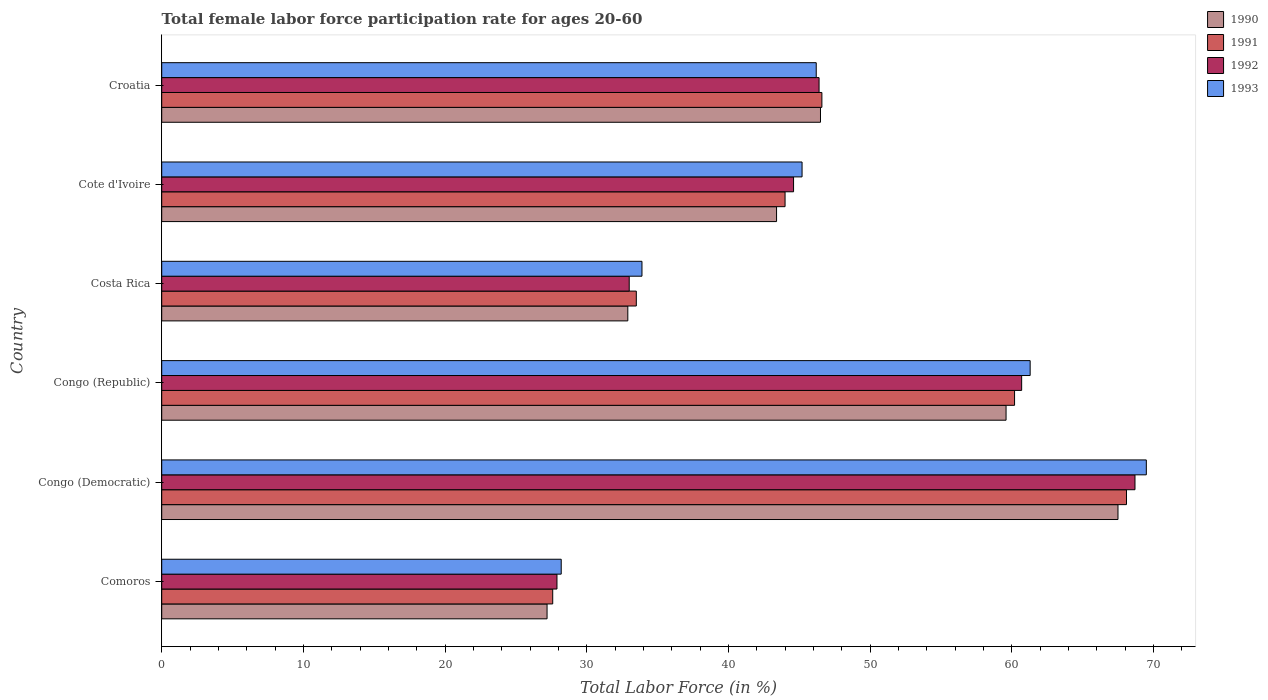Are the number of bars per tick equal to the number of legend labels?
Ensure brevity in your answer.  Yes. Are the number of bars on each tick of the Y-axis equal?
Your answer should be very brief. Yes. What is the label of the 2nd group of bars from the top?
Provide a short and direct response. Cote d'Ivoire. In how many cases, is the number of bars for a given country not equal to the number of legend labels?
Ensure brevity in your answer.  0. What is the female labor force participation rate in 1990 in Congo (Democratic)?
Your response must be concise. 67.5. Across all countries, what is the maximum female labor force participation rate in 1990?
Your answer should be very brief. 67.5. Across all countries, what is the minimum female labor force participation rate in 1993?
Give a very brief answer. 28.2. In which country was the female labor force participation rate in 1990 maximum?
Your response must be concise. Congo (Democratic). In which country was the female labor force participation rate in 1993 minimum?
Give a very brief answer. Comoros. What is the total female labor force participation rate in 1991 in the graph?
Provide a succinct answer. 280. What is the difference between the female labor force participation rate in 1990 in Comoros and that in Cote d'Ivoire?
Your response must be concise. -16.2. What is the difference between the female labor force participation rate in 1992 in Comoros and the female labor force participation rate in 1990 in Cote d'Ivoire?
Offer a very short reply. -15.5. What is the average female labor force participation rate in 1991 per country?
Provide a short and direct response. 46.67. In how many countries, is the female labor force participation rate in 1991 greater than 66 %?
Keep it short and to the point. 1. What is the ratio of the female labor force participation rate in 1991 in Comoros to that in Croatia?
Offer a terse response. 0.59. What is the difference between the highest and the second highest female labor force participation rate in 1990?
Offer a very short reply. 7.9. What is the difference between the highest and the lowest female labor force participation rate in 1992?
Keep it short and to the point. 40.8. In how many countries, is the female labor force participation rate in 1991 greater than the average female labor force participation rate in 1991 taken over all countries?
Offer a terse response. 2. Is the sum of the female labor force participation rate in 1990 in Congo (Republic) and Cote d'Ivoire greater than the maximum female labor force participation rate in 1992 across all countries?
Your response must be concise. Yes. What does the 4th bar from the top in Congo (Democratic) represents?
Make the answer very short. 1990. Is it the case that in every country, the sum of the female labor force participation rate in 1990 and female labor force participation rate in 1993 is greater than the female labor force participation rate in 1991?
Offer a terse response. Yes. How many bars are there?
Keep it short and to the point. 24. How many countries are there in the graph?
Give a very brief answer. 6. Where does the legend appear in the graph?
Your answer should be very brief. Top right. How many legend labels are there?
Make the answer very short. 4. What is the title of the graph?
Your answer should be compact. Total female labor force participation rate for ages 20-60. What is the label or title of the X-axis?
Provide a short and direct response. Total Labor Force (in %). What is the Total Labor Force (in %) in 1990 in Comoros?
Your answer should be compact. 27.2. What is the Total Labor Force (in %) in 1991 in Comoros?
Offer a very short reply. 27.6. What is the Total Labor Force (in %) of 1992 in Comoros?
Provide a succinct answer. 27.9. What is the Total Labor Force (in %) in 1993 in Comoros?
Offer a very short reply. 28.2. What is the Total Labor Force (in %) in 1990 in Congo (Democratic)?
Your answer should be very brief. 67.5. What is the Total Labor Force (in %) of 1991 in Congo (Democratic)?
Keep it short and to the point. 68.1. What is the Total Labor Force (in %) of 1992 in Congo (Democratic)?
Give a very brief answer. 68.7. What is the Total Labor Force (in %) in 1993 in Congo (Democratic)?
Provide a short and direct response. 69.5. What is the Total Labor Force (in %) of 1990 in Congo (Republic)?
Make the answer very short. 59.6. What is the Total Labor Force (in %) in 1991 in Congo (Republic)?
Ensure brevity in your answer.  60.2. What is the Total Labor Force (in %) in 1992 in Congo (Republic)?
Your answer should be very brief. 60.7. What is the Total Labor Force (in %) in 1993 in Congo (Republic)?
Offer a very short reply. 61.3. What is the Total Labor Force (in %) in 1990 in Costa Rica?
Provide a succinct answer. 32.9. What is the Total Labor Force (in %) of 1991 in Costa Rica?
Your answer should be compact. 33.5. What is the Total Labor Force (in %) in 1992 in Costa Rica?
Your response must be concise. 33. What is the Total Labor Force (in %) of 1993 in Costa Rica?
Provide a short and direct response. 33.9. What is the Total Labor Force (in %) in 1990 in Cote d'Ivoire?
Your response must be concise. 43.4. What is the Total Labor Force (in %) of 1991 in Cote d'Ivoire?
Offer a terse response. 44. What is the Total Labor Force (in %) of 1992 in Cote d'Ivoire?
Your response must be concise. 44.6. What is the Total Labor Force (in %) of 1993 in Cote d'Ivoire?
Keep it short and to the point. 45.2. What is the Total Labor Force (in %) in 1990 in Croatia?
Make the answer very short. 46.5. What is the Total Labor Force (in %) in 1991 in Croatia?
Your response must be concise. 46.6. What is the Total Labor Force (in %) of 1992 in Croatia?
Offer a terse response. 46.4. What is the Total Labor Force (in %) in 1993 in Croatia?
Give a very brief answer. 46.2. Across all countries, what is the maximum Total Labor Force (in %) of 1990?
Keep it short and to the point. 67.5. Across all countries, what is the maximum Total Labor Force (in %) in 1991?
Your answer should be very brief. 68.1. Across all countries, what is the maximum Total Labor Force (in %) of 1992?
Your answer should be compact. 68.7. Across all countries, what is the maximum Total Labor Force (in %) in 1993?
Provide a short and direct response. 69.5. Across all countries, what is the minimum Total Labor Force (in %) in 1990?
Make the answer very short. 27.2. Across all countries, what is the minimum Total Labor Force (in %) in 1991?
Offer a terse response. 27.6. Across all countries, what is the minimum Total Labor Force (in %) in 1992?
Make the answer very short. 27.9. Across all countries, what is the minimum Total Labor Force (in %) of 1993?
Offer a very short reply. 28.2. What is the total Total Labor Force (in %) of 1990 in the graph?
Offer a terse response. 277.1. What is the total Total Labor Force (in %) in 1991 in the graph?
Give a very brief answer. 280. What is the total Total Labor Force (in %) in 1992 in the graph?
Your answer should be compact. 281.3. What is the total Total Labor Force (in %) in 1993 in the graph?
Your response must be concise. 284.3. What is the difference between the Total Labor Force (in %) of 1990 in Comoros and that in Congo (Democratic)?
Make the answer very short. -40.3. What is the difference between the Total Labor Force (in %) of 1991 in Comoros and that in Congo (Democratic)?
Give a very brief answer. -40.5. What is the difference between the Total Labor Force (in %) in 1992 in Comoros and that in Congo (Democratic)?
Offer a terse response. -40.8. What is the difference between the Total Labor Force (in %) in 1993 in Comoros and that in Congo (Democratic)?
Give a very brief answer. -41.3. What is the difference between the Total Labor Force (in %) in 1990 in Comoros and that in Congo (Republic)?
Your answer should be very brief. -32.4. What is the difference between the Total Labor Force (in %) of 1991 in Comoros and that in Congo (Republic)?
Your response must be concise. -32.6. What is the difference between the Total Labor Force (in %) in 1992 in Comoros and that in Congo (Republic)?
Ensure brevity in your answer.  -32.8. What is the difference between the Total Labor Force (in %) in 1993 in Comoros and that in Congo (Republic)?
Offer a terse response. -33.1. What is the difference between the Total Labor Force (in %) in 1990 in Comoros and that in Costa Rica?
Offer a terse response. -5.7. What is the difference between the Total Labor Force (in %) of 1991 in Comoros and that in Costa Rica?
Provide a short and direct response. -5.9. What is the difference between the Total Labor Force (in %) in 1992 in Comoros and that in Costa Rica?
Offer a terse response. -5.1. What is the difference between the Total Labor Force (in %) of 1990 in Comoros and that in Cote d'Ivoire?
Provide a succinct answer. -16.2. What is the difference between the Total Labor Force (in %) of 1991 in Comoros and that in Cote d'Ivoire?
Your answer should be very brief. -16.4. What is the difference between the Total Labor Force (in %) in 1992 in Comoros and that in Cote d'Ivoire?
Make the answer very short. -16.7. What is the difference between the Total Labor Force (in %) of 1993 in Comoros and that in Cote d'Ivoire?
Your answer should be very brief. -17. What is the difference between the Total Labor Force (in %) of 1990 in Comoros and that in Croatia?
Provide a succinct answer. -19.3. What is the difference between the Total Labor Force (in %) in 1991 in Comoros and that in Croatia?
Your answer should be compact. -19. What is the difference between the Total Labor Force (in %) of 1992 in Comoros and that in Croatia?
Provide a short and direct response. -18.5. What is the difference between the Total Labor Force (in %) in 1990 in Congo (Democratic) and that in Costa Rica?
Make the answer very short. 34.6. What is the difference between the Total Labor Force (in %) of 1991 in Congo (Democratic) and that in Costa Rica?
Your answer should be very brief. 34.6. What is the difference between the Total Labor Force (in %) of 1992 in Congo (Democratic) and that in Costa Rica?
Your answer should be compact. 35.7. What is the difference between the Total Labor Force (in %) in 1993 in Congo (Democratic) and that in Costa Rica?
Make the answer very short. 35.6. What is the difference between the Total Labor Force (in %) of 1990 in Congo (Democratic) and that in Cote d'Ivoire?
Ensure brevity in your answer.  24.1. What is the difference between the Total Labor Force (in %) of 1991 in Congo (Democratic) and that in Cote d'Ivoire?
Provide a short and direct response. 24.1. What is the difference between the Total Labor Force (in %) in 1992 in Congo (Democratic) and that in Cote d'Ivoire?
Provide a succinct answer. 24.1. What is the difference between the Total Labor Force (in %) in 1993 in Congo (Democratic) and that in Cote d'Ivoire?
Your response must be concise. 24.3. What is the difference between the Total Labor Force (in %) in 1990 in Congo (Democratic) and that in Croatia?
Your answer should be compact. 21. What is the difference between the Total Labor Force (in %) of 1992 in Congo (Democratic) and that in Croatia?
Your response must be concise. 22.3. What is the difference between the Total Labor Force (in %) in 1993 in Congo (Democratic) and that in Croatia?
Your answer should be compact. 23.3. What is the difference between the Total Labor Force (in %) in 1990 in Congo (Republic) and that in Costa Rica?
Offer a terse response. 26.7. What is the difference between the Total Labor Force (in %) in 1991 in Congo (Republic) and that in Costa Rica?
Make the answer very short. 26.7. What is the difference between the Total Labor Force (in %) of 1992 in Congo (Republic) and that in Costa Rica?
Your answer should be compact. 27.7. What is the difference between the Total Labor Force (in %) of 1993 in Congo (Republic) and that in Costa Rica?
Your answer should be very brief. 27.4. What is the difference between the Total Labor Force (in %) in 1990 in Congo (Republic) and that in Croatia?
Ensure brevity in your answer.  13.1. What is the difference between the Total Labor Force (in %) in 1991 in Congo (Republic) and that in Croatia?
Give a very brief answer. 13.6. What is the difference between the Total Labor Force (in %) of 1992 in Congo (Republic) and that in Croatia?
Provide a succinct answer. 14.3. What is the difference between the Total Labor Force (in %) in 1990 in Costa Rica and that in Cote d'Ivoire?
Make the answer very short. -10.5. What is the difference between the Total Labor Force (in %) of 1992 in Costa Rica and that in Cote d'Ivoire?
Keep it short and to the point. -11.6. What is the difference between the Total Labor Force (in %) in 1993 in Costa Rica and that in Cote d'Ivoire?
Give a very brief answer. -11.3. What is the difference between the Total Labor Force (in %) in 1991 in Costa Rica and that in Croatia?
Your answer should be very brief. -13.1. What is the difference between the Total Labor Force (in %) in 1993 in Costa Rica and that in Croatia?
Provide a short and direct response. -12.3. What is the difference between the Total Labor Force (in %) of 1990 in Cote d'Ivoire and that in Croatia?
Keep it short and to the point. -3.1. What is the difference between the Total Labor Force (in %) in 1992 in Cote d'Ivoire and that in Croatia?
Make the answer very short. -1.8. What is the difference between the Total Labor Force (in %) of 1993 in Cote d'Ivoire and that in Croatia?
Your answer should be compact. -1. What is the difference between the Total Labor Force (in %) of 1990 in Comoros and the Total Labor Force (in %) of 1991 in Congo (Democratic)?
Offer a terse response. -40.9. What is the difference between the Total Labor Force (in %) of 1990 in Comoros and the Total Labor Force (in %) of 1992 in Congo (Democratic)?
Keep it short and to the point. -41.5. What is the difference between the Total Labor Force (in %) of 1990 in Comoros and the Total Labor Force (in %) of 1993 in Congo (Democratic)?
Provide a short and direct response. -42.3. What is the difference between the Total Labor Force (in %) in 1991 in Comoros and the Total Labor Force (in %) in 1992 in Congo (Democratic)?
Provide a short and direct response. -41.1. What is the difference between the Total Labor Force (in %) in 1991 in Comoros and the Total Labor Force (in %) in 1993 in Congo (Democratic)?
Make the answer very short. -41.9. What is the difference between the Total Labor Force (in %) in 1992 in Comoros and the Total Labor Force (in %) in 1993 in Congo (Democratic)?
Your answer should be very brief. -41.6. What is the difference between the Total Labor Force (in %) in 1990 in Comoros and the Total Labor Force (in %) in 1991 in Congo (Republic)?
Make the answer very short. -33. What is the difference between the Total Labor Force (in %) of 1990 in Comoros and the Total Labor Force (in %) of 1992 in Congo (Republic)?
Offer a very short reply. -33.5. What is the difference between the Total Labor Force (in %) in 1990 in Comoros and the Total Labor Force (in %) in 1993 in Congo (Republic)?
Offer a terse response. -34.1. What is the difference between the Total Labor Force (in %) of 1991 in Comoros and the Total Labor Force (in %) of 1992 in Congo (Republic)?
Ensure brevity in your answer.  -33.1. What is the difference between the Total Labor Force (in %) of 1991 in Comoros and the Total Labor Force (in %) of 1993 in Congo (Republic)?
Offer a very short reply. -33.7. What is the difference between the Total Labor Force (in %) in 1992 in Comoros and the Total Labor Force (in %) in 1993 in Congo (Republic)?
Offer a very short reply. -33.4. What is the difference between the Total Labor Force (in %) of 1990 in Comoros and the Total Labor Force (in %) of 1992 in Costa Rica?
Offer a terse response. -5.8. What is the difference between the Total Labor Force (in %) in 1991 in Comoros and the Total Labor Force (in %) in 1993 in Costa Rica?
Offer a terse response. -6.3. What is the difference between the Total Labor Force (in %) in 1992 in Comoros and the Total Labor Force (in %) in 1993 in Costa Rica?
Offer a very short reply. -6. What is the difference between the Total Labor Force (in %) of 1990 in Comoros and the Total Labor Force (in %) of 1991 in Cote d'Ivoire?
Make the answer very short. -16.8. What is the difference between the Total Labor Force (in %) of 1990 in Comoros and the Total Labor Force (in %) of 1992 in Cote d'Ivoire?
Offer a very short reply. -17.4. What is the difference between the Total Labor Force (in %) of 1991 in Comoros and the Total Labor Force (in %) of 1992 in Cote d'Ivoire?
Keep it short and to the point. -17. What is the difference between the Total Labor Force (in %) in 1991 in Comoros and the Total Labor Force (in %) in 1993 in Cote d'Ivoire?
Give a very brief answer. -17.6. What is the difference between the Total Labor Force (in %) in 1992 in Comoros and the Total Labor Force (in %) in 1993 in Cote d'Ivoire?
Your answer should be very brief. -17.3. What is the difference between the Total Labor Force (in %) in 1990 in Comoros and the Total Labor Force (in %) in 1991 in Croatia?
Make the answer very short. -19.4. What is the difference between the Total Labor Force (in %) in 1990 in Comoros and the Total Labor Force (in %) in 1992 in Croatia?
Keep it short and to the point. -19.2. What is the difference between the Total Labor Force (in %) in 1990 in Comoros and the Total Labor Force (in %) in 1993 in Croatia?
Offer a very short reply. -19. What is the difference between the Total Labor Force (in %) of 1991 in Comoros and the Total Labor Force (in %) of 1992 in Croatia?
Your answer should be very brief. -18.8. What is the difference between the Total Labor Force (in %) of 1991 in Comoros and the Total Labor Force (in %) of 1993 in Croatia?
Make the answer very short. -18.6. What is the difference between the Total Labor Force (in %) of 1992 in Comoros and the Total Labor Force (in %) of 1993 in Croatia?
Give a very brief answer. -18.3. What is the difference between the Total Labor Force (in %) of 1990 in Congo (Democratic) and the Total Labor Force (in %) of 1991 in Congo (Republic)?
Offer a very short reply. 7.3. What is the difference between the Total Labor Force (in %) in 1990 in Congo (Democratic) and the Total Labor Force (in %) in 1992 in Congo (Republic)?
Provide a short and direct response. 6.8. What is the difference between the Total Labor Force (in %) in 1991 in Congo (Democratic) and the Total Labor Force (in %) in 1992 in Congo (Republic)?
Your answer should be very brief. 7.4. What is the difference between the Total Labor Force (in %) in 1990 in Congo (Democratic) and the Total Labor Force (in %) in 1992 in Costa Rica?
Your response must be concise. 34.5. What is the difference between the Total Labor Force (in %) of 1990 in Congo (Democratic) and the Total Labor Force (in %) of 1993 in Costa Rica?
Provide a short and direct response. 33.6. What is the difference between the Total Labor Force (in %) in 1991 in Congo (Democratic) and the Total Labor Force (in %) in 1992 in Costa Rica?
Keep it short and to the point. 35.1. What is the difference between the Total Labor Force (in %) in 1991 in Congo (Democratic) and the Total Labor Force (in %) in 1993 in Costa Rica?
Keep it short and to the point. 34.2. What is the difference between the Total Labor Force (in %) of 1992 in Congo (Democratic) and the Total Labor Force (in %) of 1993 in Costa Rica?
Ensure brevity in your answer.  34.8. What is the difference between the Total Labor Force (in %) of 1990 in Congo (Democratic) and the Total Labor Force (in %) of 1991 in Cote d'Ivoire?
Offer a very short reply. 23.5. What is the difference between the Total Labor Force (in %) in 1990 in Congo (Democratic) and the Total Labor Force (in %) in 1992 in Cote d'Ivoire?
Your answer should be very brief. 22.9. What is the difference between the Total Labor Force (in %) in 1990 in Congo (Democratic) and the Total Labor Force (in %) in 1993 in Cote d'Ivoire?
Provide a short and direct response. 22.3. What is the difference between the Total Labor Force (in %) of 1991 in Congo (Democratic) and the Total Labor Force (in %) of 1992 in Cote d'Ivoire?
Provide a short and direct response. 23.5. What is the difference between the Total Labor Force (in %) of 1991 in Congo (Democratic) and the Total Labor Force (in %) of 1993 in Cote d'Ivoire?
Make the answer very short. 22.9. What is the difference between the Total Labor Force (in %) in 1990 in Congo (Democratic) and the Total Labor Force (in %) in 1991 in Croatia?
Provide a short and direct response. 20.9. What is the difference between the Total Labor Force (in %) in 1990 in Congo (Democratic) and the Total Labor Force (in %) in 1992 in Croatia?
Your answer should be compact. 21.1. What is the difference between the Total Labor Force (in %) of 1990 in Congo (Democratic) and the Total Labor Force (in %) of 1993 in Croatia?
Your answer should be compact. 21.3. What is the difference between the Total Labor Force (in %) of 1991 in Congo (Democratic) and the Total Labor Force (in %) of 1992 in Croatia?
Your answer should be compact. 21.7. What is the difference between the Total Labor Force (in %) in 1991 in Congo (Democratic) and the Total Labor Force (in %) in 1993 in Croatia?
Your response must be concise. 21.9. What is the difference between the Total Labor Force (in %) of 1992 in Congo (Democratic) and the Total Labor Force (in %) of 1993 in Croatia?
Ensure brevity in your answer.  22.5. What is the difference between the Total Labor Force (in %) of 1990 in Congo (Republic) and the Total Labor Force (in %) of 1991 in Costa Rica?
Your answer should be compact. 26.1. What is the difference between the Total Labor Force (in %) in 1990 in Congo (Republic) and the Total Labor Force (in %) in 1992 in Costa Rica?
Your answer should be very brief. 26.6. What is the difference between the Total Labor Force (in %) of 1990 in Congo (Republic) and the Total Labor Force (in %) of 1993 in Costa Rica?
Provide a short and direct response. 25.7. What is the difference between the Total Labor Force (in %) in 1991 in Congo (Republic) and the Total Labor Force (in %) in 1992 in Costa Rica?
Keep it short and to the point. 27.2. What is the difference between the Total Labor Force (in %) in 1991 in Congo (Republic) and the Total Labor Force (in %) in 1993 in Costa Rica?
Your response must be concise. 26.3. What is the difference between the Total Labor Force (in %) in 1992 in Congo (Republic) and the Total Labor Force (in %) in 1993 in Costa Rica?
Give a very brief answer. 26.8. What is the difference between the Total Labor Force (in %) in 1990 in Congo (Republic) and the Total Labor Force (in %) in 1991 in Cote d'Ivoire?
Your answer should be very brief. 15.6. What is the difference between the Total Labor Force (in %) of 1991 in Congo (Republic) and the Total Labor Force (in %) of 1993 in Cote d'Ivoire?
Offer a very short reply. 15. What is the difference between the Total Labor Force (in %) of 1992 in Congo (Republic) and the Total Labor Force (in %) of 1993 in Cote d'Ivoire?
Ensure brevity in your answer.  15.5. What is the difference between the Total Labor Force (in %) in 1990 in Congo (Republic) and the Total Labor Force (in %) in 1991 in Croatia?
Offer a terse response. 13. What is the difference between the Total Labor Force (in %) in 1991 in Congo (Republic) and the Total Labor Force (in %) in 1992 in Croatia?
Offer a terse response. 13.8. What is the difference between the Total Labor Force (in %) of 1991 in Congo (Republic) and the Total Labor Force (in %) of 1993 in Croatia?
Your answer should be compact. 14. What is the difference between the Total Labor Force (in %) in 1990 in Costa Rica and the Total Labor Force (in %) in 1993 in Cote d'Ivoire?
Offer a terse response. -12.3. What is the difference between the Total Labor Force (in %) of 1991 in Costa Rica and the Total Labor Force (in %) of 1992 in Cote d'Ivoire?
Give a very brief answer. -11.1. What is the difference between the Total Labor Force (in %) of 1990 in Costa Rica and the Total Labor Force (in %) of 1991 in Croatia?
Give a very brief answer. -13.7. What is the difference between the Total Labor Force (in %) in 1990 in Costa Rica and the Total Labor Force (in %) in 1993 in Croatia?
Your answer should be compact. -13.3. What is the difference between the Total Labor Force (in %) of 1991 in Costa Rica and the Total Labor Force (in %) of 1993 in Croatia?
Your response must be concise. -12.7. What is the difference between the Total Labor Force (in %) of 1990 in Cote d'Ivoire and the Total Labor Force (in %) of 1991 in Croatia?
Your answer should be compact. -3.2. What is the difference between the Total Labor Force (in %) in 1990 in Cote d'Ivoire and the Total Labor Force (in %) in 1993 in Croatia?
Offer a terse response. -2.8. What is the difference between the Total Labor Force (in %) in 1991 in Cote d'Ivoire and the Total Labor Force (in %) in 1993 in Croatia?
Keep it short and to the point. -2.2. What is the average Total Labor Force (in %) of 1990 per country?
Offer a very short reply. 46.18. What is the average Total Labor Force (in %) in 1991 per country?
Keep it short and to the point. 46.67. What is the average Total Labor Force (in %) of 1992 per country?
Your answer should be very brief. 46.88. What is the average Total Labor Force (in %) of 1993 per country?
Your answer should be compact. 47.38. What is the difference between the Total Labor Force (in %) of 1990 and Total Labor Force (in %) of 1991 in Comoros?
Keep it short and to the point. -0.4. What is the difference between the Total Labor Force (in %) of 1991 and Total Labor Force (in %) of 1992 in Comoros?
Keep it short and to the point. -0.3. What is the difference between the Total Labor Force (in %) of 1992 and Total Labor Force (in %) of 1993 in Comoros?
Your response must be concise. -0.3. What is the difference between the Total Labor Force (in %) of 1990 and Total Labor Force (in %) of 1991 in Congo (Democratic)?
Keep it short and to the point. -0.6. What is the difference between the Total Labor Force (in %) in 1990 and Total Labor Force (in %) in 1992 in Congo (Democratic)?
Give a very brief answer. -1.2. What is the difference between the Total Labor Force (in %) in 1990 and Total Labor Force (in %) in 1993 in Congo (Democratic)?
Your answer should be compact. -2. What is the difference between the Total Labor Force (in %) of 1991 and Total Labor Force (in %) of 1993 in Congo (Democratic)?
Give a very brief answer. -1.4. What is the difference between the Total Labor Force (in %) in 1992 and Total Labor Force (in %) in 1993 in Congo (Democratic)?
Give a very brief answer. -0.8. What is the difference between the Total Labor Force (in %) of 1990 and Total Labor Force (in %) of 1991 in Congo (Republic)?
Provide a short and direct response. -0.6. What is the difference between the Total Labor Force (in %) of 1990 and Total Labor Force (in %) of 1992 in Congo (Republic)?
Offer a terse response. -1.1. What is the difference between the Total Labor Force (in %) in 1990 and Total Labor Force (in %) in 1993 in Congo (Republic)?
Offer a very short reply. -1.7. What is the difference between the Total Labor Force (in %) of 1990 and Total Labor Force (in %) of 1991 in Costa Rica?
Offer a very short reply. -0.6. What is the difference between the Total Labor Force (in %) of 1990 and Total Labor Force (in %) of 1992 in Costa Rica?
Provide a succinct answer. -0.1. What is the difference between the Total Labor Force (in %) of 1991 and Total Labor Force (in %) of 1993 in Costa Rica?
Provide a succinct answer. -0.4. What is the difference between the Total Labor Force (in %) in 1990 and Total Labor Force (in %) in 1991 in Cote d'Ivoire?
Ensure brevity in your answer.  -0.6. What is the difference between the Total Labor Force (in %) of 1990 and Total Labor Force (in %) of 1993 in Cote d'Ivoire?
Your response must be concise. -1.8. What is the difference between the Total Labor Force (in %) of 1991 and Total Labor Force (in %) of 1993 in Cote d'Ivoire?
Keep it short and to the point. -1.2. What is the difference between the Total Labor Force (in %) in 1990 and Total Labor Force (in %) in 1991 in Croatia?
Make the answer very short. -0.1. What is the ratio of the Total Labor Force (in %) of 1990 in Comoros to that in Congo (Democratic)?
Offer a terse response. 0.4. What is the ratio of the Total Labor Force (in %) in 1991 in Comoros to that in Congo (Democratic)?
Your response must be concise. 0.41. What is the ratio of the Total Labor Force (in %) in 1992 in Comoros to that in Congo (Democratic)?
Keep it short and to the point. 0.41. What is the ratio of the Total Labor Force (in %) of 1993 in Comoros to that in Congo (Democratic)?
Offer a terse response. 0.41. What is the ratio of the Total Labor Force (in %) in 1990 in Comoros to that in Congo (Republic)?
Your answer should be very brief. 0.46. What is the ratio of the Total Labor Force (in %) of 1991 in Comoros to that in Congo (Republic)?
Offer a terse response. 0.46. What is the ratio of the Total Labor Force (in %) of 1992 in Comoros to that in Congo (Republic)?
Your response must be concise. 0.46. What is the ratio of the Total Labor Force (in %) in 1993 in Comoros to that in Congo (Republic)?
Give a very brief answer. 0.46. What is the ratio of the Total Labor Force (in %) in 1990 in Comoros to that in Costa Rica?
Offer a terse response. 0.83. What is the ratio of the Total Labor Force (in %) of 1991 in Comoros to that in Costa Rica?
Keep it short and to the point. 0.82. What is the ratio of the Total Labor Force (in %) in 1992 in Comoros to that in Costa Rica?
Keep it short and to the point. 0.85. What is the ratio of the Total Labor Force (in %) of 1993 in Comoros to that in Costa Rica?
Keep it short and to the point. 0.83. What is the ratio of the Total Labor Force (in %) of 1990 in Comoros to that in Cote d'Ivoire?
Your response must be concise. 0.63. What is the ratio of the Total Labor Force (in %) of 1991 in Comoros to that in Cote d'Ivoire?
Your response must be concise. 0.63. What is the ratio of the Total Labor Force (in %) in 1992 in Comoros to that in Cote d'Ivoire?
Provide a short and direct response. 0.63. What is the ratio of the Total Labor Force (in %) of 1993 in Comoros to that in Cote d'Ivoire?
Offer a terse response. 0.62. What is the ratio of the Total Labor Force (in %) of 1990 in Comoros to that in Croatia?
Keep it short and to the point. 0.58. What is the ratio of the Total Labor Force (in %) of 1991 in Comoros to that in Croatia?
Your answer should be compact. 0.59. What is the ratio of the Total Labor Force (in %) of 1992 in Comoros to that in Croatia?
Give a very brief answer. 0.6. What is the ratio of the Total Labor Force (in %) of 1993 in Comoros to that in Croatia?
Provide a short and direct response. 0.61. What is the ratio of the Total Labor Force (in %) in 1990 in Congo (Democratic) to that in Congo (Republic)?
Provide a succinct answer. 1.13. What is the ratio of the Total Labor Force (in %) of 1991 in Congo (Democratic) to that in Congo (Republic)?
Provide a succinct answer. 1.13. What is the ratio of the Total Labor Force (in %) of 1992 in Congo (Democratic) to that in Congo (Republic)?
Offer a very short reply. 1.13. What is the ratio of the Total Labor Force (in %) in 1993 in Congo (Democratic) to that in Congo (Republic)?
Make the answer very short. 1.13. What is the ratio of the Total Labor Force (in %) in 1990 in Congo (Democratic) to that in Costa Rica?
Offer a very short reply. 2.05. What is the ratio of the Total Labor Force (in %) in 1991 in Congo (Democratic) to that in Costa Rica?
Give a very brief answer. 2.03. What is the ratio of the Total Labor Force (in %) in 1992 in Congo (Democratic) to that in Costa Rica?
Ensure brevity in your answer.  2.08. What is the ratio of the Total Labor Force (in %) in 1993 in Congo (Democratic) to that in Costa Rica?
Your answer should be compact. 2.05. What is the ratio of the Total Labor Force (in %) of 1990 in Congo (Democratic) to that in Cote d'Ivoire?
Give a very brief answer. 1.56. What is the ratio of the Total Labor Force (in %) of 1991 in Congo (Democratic) to that in Cote d'Ivoire?
Your answer should be compact. 1.55. What is the ratio of the Total Labor Force (in %) of 1992 in Congo (Democratic) to that in Cote d'Ivoire?
Give a very brief answer. 1.54. What is the ratio of the Total Labor Force (in %) in 1993 in Congo (Democratic) to that in Cote d'Ivoire?
Give a very brief answer. 1.54. What is the ratio of the Total Labor Force (in %) of 1990 in Congo (Democratic) to that in Croatia?
Give a very brief answer. 1.45. What is the ratio of the Total Labor Force (in %) of 1991 in Congo (Democratic) to that in Croatia?
Offer a terse response. 1.46. What is the ratio of the Total Labor Force (in %) in 1992 in Congo (Democratic) to that in Croatia?
Keep it short and to the point. 1.48. What is the ratio of the Total Labor Force (in %) of 1993 in Congo (Democratic) to that in Croatia?
Provide a succinct answer. 1.5. What is the ratio of the Total Labor Force (in %) of 1990 in Congo (Republic) to that in Costa Rica?
Your answer should be very brief. 1.81. What is the ratio of the Total Labor Force (in %) of 1991 in Congo (Republic) to that in Costa Rica?
Provide a succinct answer. 1.8. What is the ratio of the Total Labor Force (in %) of 1992 in Congo (Republic) to that in Costa Rica?
Provide a short and direct response. 1.84. What is the ratio of the Total Labor Force (in %) in 1993 in Congo (Republic) to that in Costa Rica?
Provide a succinct answer. 1.81. What is the ratio of the Total Labor Force (in %) in 1990 in Congo (Republic) to that in Cote d'Ivoire?
Offer a very short reply. 1.37. What is the ratio of the Total Labor Force (in %) in 1991 in Congo (Republic) to that in Cote d'Ivoire?
Give a very brief answer. 1.37. What is the ratio of the Total Labor Force (in %) of 1992 in Congo (Republic) to that in Cote d'Ivoire?
Make the answer very short. 1.36. What is the ratio of the Total Labor Force (in %) of 1993 in Congo (Republic) to that in Cote d'Ivoire?
Keep it short and to the point. 1.36. What is the ratio of the Total Labor Force (in %) in 1990 in Congo (Republic) to that in Croatia?
Provide a short and direct response. 1.28. What is the ratio of the Total Labor Force (in %) of 1991 in Congo (Republic) to that in Croatia?
Give a very brief answer. 1.29. What is the ratio of the Total Labor Force (in %) in 1992 in Congo (Republic) to that in Croatia?
Your answer should be very brief. 1.31. What is the ratio of the Total Labor Force (in %) in 1993 in Congo (Republic) to that in Croatia?
Keep it short and to the point. 1.33. What is the ratio of the Total Labor Force (in %) in 1990 in Costa Rica to that in Cote d'Ivoire?
Your answer should be very brief. 0.76. What is the ratio of the Total Labor Force (in %) in 1991 in Costa Rica to that in Cote d'Ivoire?
Provide a succinct answer. 0.76. What is the ratio of the Total Labor Force (in %) in 1992 in Costa Rica to that in Cote d'Ivoire?
Your answer should be very brief. 0.74. What is the ratio of the Total Labor Force (in %) in 1990 in Costa Rica to that in Croatia?
Provide a short and direct response. 0.71. What is the ratio of the Total Labor Force (in %) in 1991 in Costa Rica to that in Croatia?
Your answer should be compact. 0.72. What is the ratio of the Total Labor Force (in %) of 1992 in Costa Rica to that in Croatia?
Provide a succinct answer. 0.71. What is the ratio of the Total Labor Force (in %) in 1993 in Costa Rica to that in Croatia?
Give a very brief answer. 0.73. What is the ratio of the Total Labor Force (in %) in 1991 in Cote d'Ivoire to that in Croatia?
Keep it short and to the point. 0.94. What is the ratio of the Total Labor Force (in %) of 1992 in Cote d'Ivoire to that in Croatia?
Your response must be concise. 0.96. What is the ratio of the Total Labor Force (in %) of 1993 in Cote d'Ivoire to that in Croatia?
Provide a succinct answer. 0.98. What is the difference between the highest and the second highest Total Labor Force (in %) of 1990?
Your response must be concise. 7.9. What is the difference between the highest and the second highest Total Labor Force (in %) in 1992?
Make the answer very short. 8. What is the difference between the highest and the second highest Total Labor Force (in %) of 1993?
Keep it short and to the point. 8.2. What is the difference between the highest and the lowest Total Labor Force (in %) of 1990?
Your answer should be compact. 40.3. What is the difference between the highest and the lowest Total Labor Force (in %) in 1991?
Ensure brevity in your answer.  40.5. What is the difference between the highest and the lowest Total Labor Force (in %) in 1992?
Ensure brevity in your answer.  40.8. What is the difference between the highest and the lowest Total Labor Force (in %) of 1993?
Your response must be concise. 41.3. 